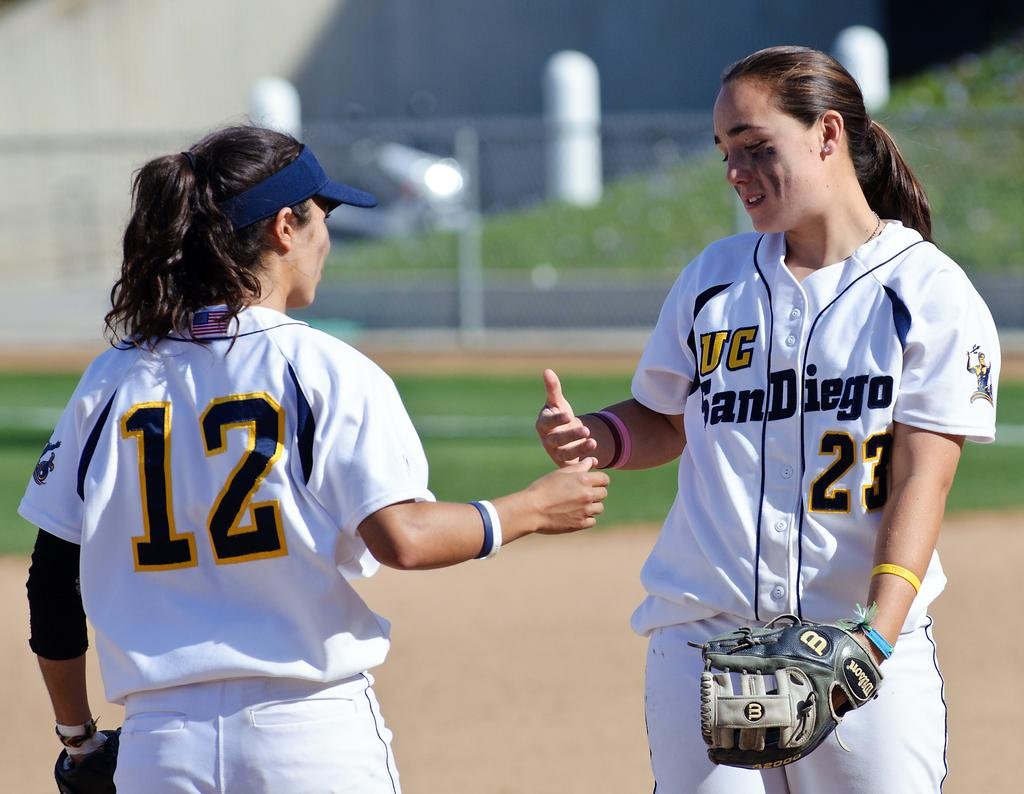<image>
Relay a brief, clear account of the picture shown. Two female softball players from the University of San Diego about to shake hands. 